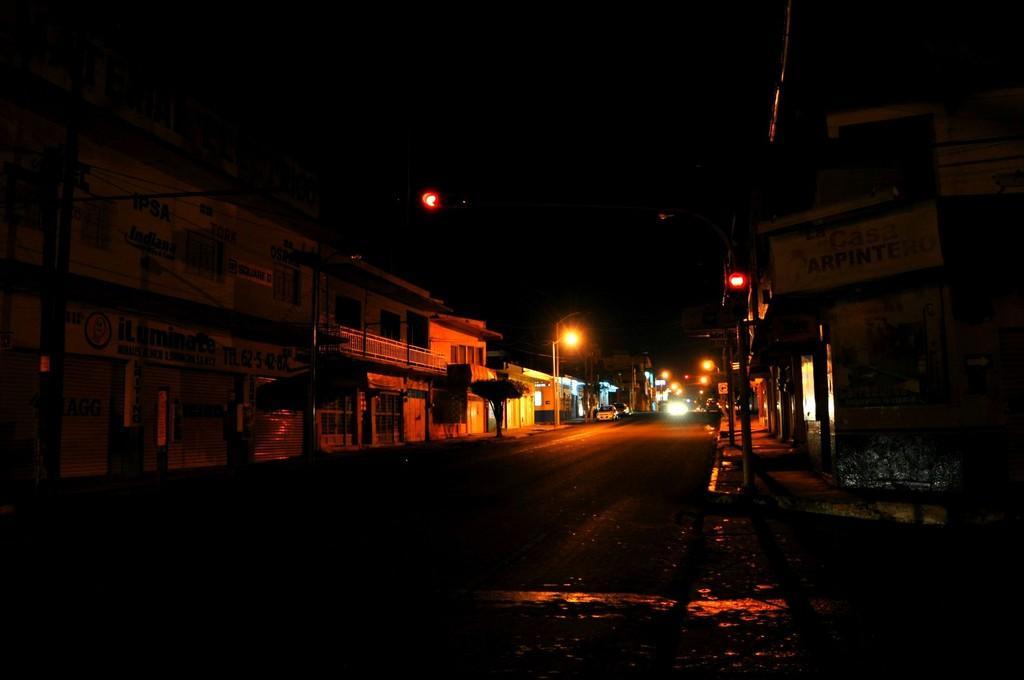Please provide a concise description of this image. In this picture we can see road, boards, buildings, poles, lights and vehicles. In the background of the image it is dark. 